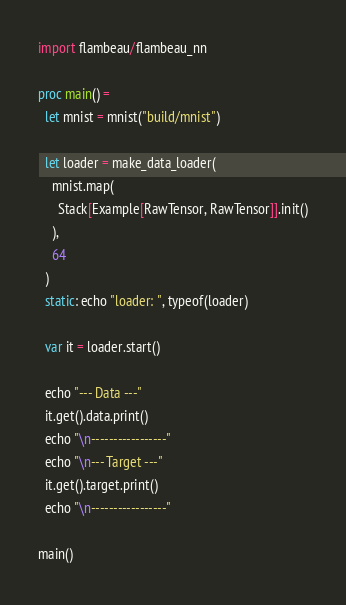<code> <loc_0><loc_0><loc_500><loc_500><_Nim_>import flambeau/flambeau_nn

proc main() =
  let mnist = mnist("build/mnist")

  let loader = make_data_loader(
    mnist.map(
      Stack[Example[RawTensor, RawTensor]].init()
    ),
    64
  )
  static: echo "loader: ", typeof(loader)

  var it = loader.start()

  echo "--- Data ---"
  it.get().data.print()
  echo "\n-----------------"
  echo "\n--- Target ---"
  it.get().target.print()
  echo "\n-----------------"

main()
</code> 